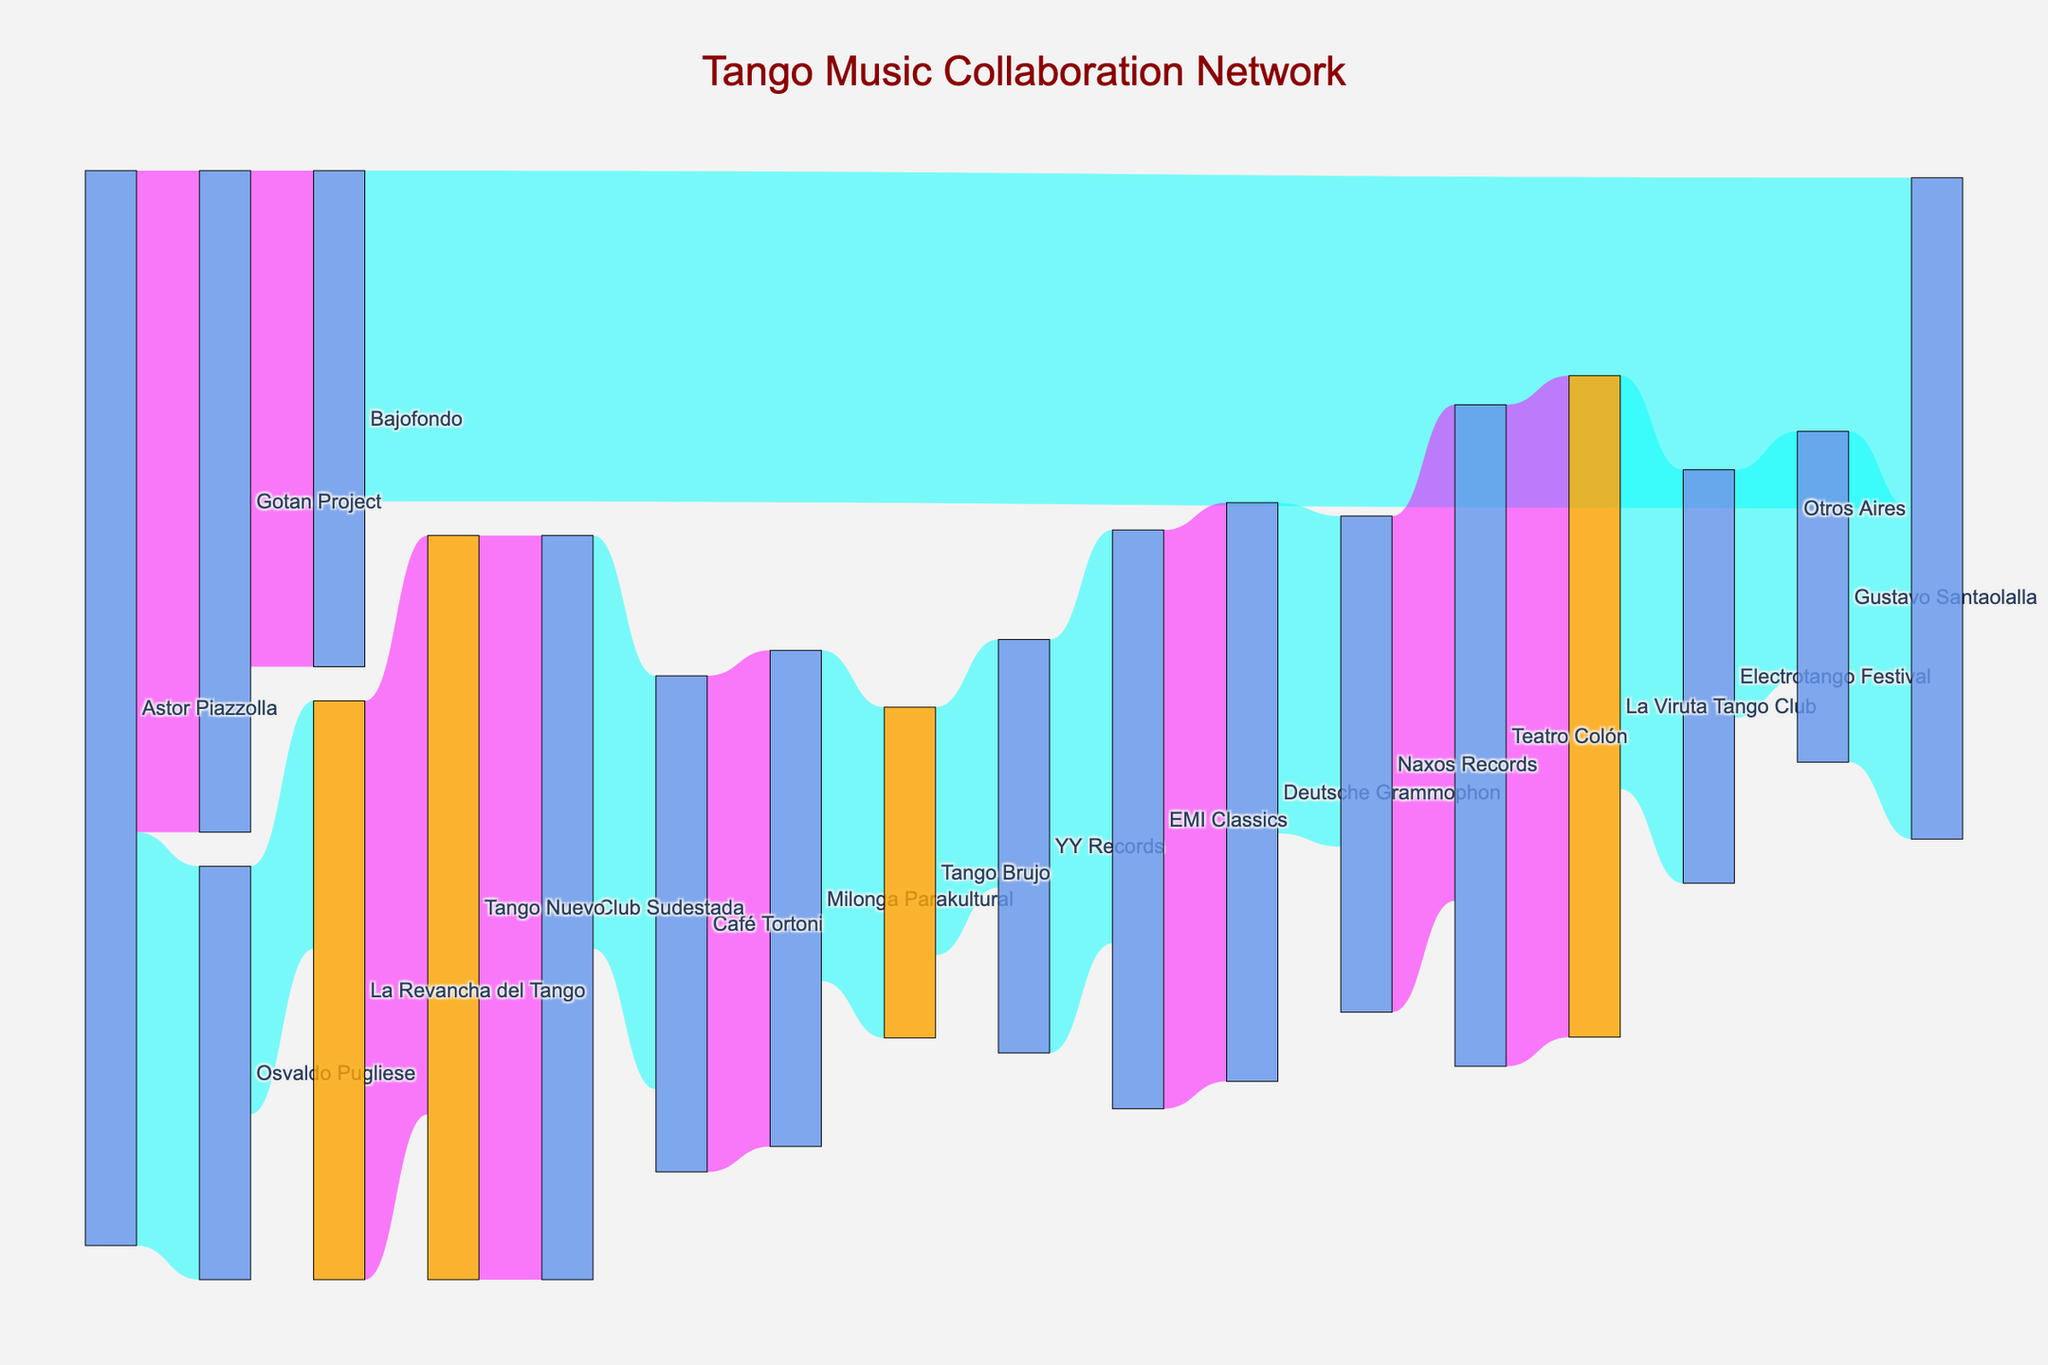how many unique nodes are present in the figure? To find the unique nodes, count all the distinct artist names, labels, and venues listed. This includes both sources and targets.
Answer: 18 what color are nodes with "Tango" in their name? Nodes with "Tango" in their name are colored with a specific hue to distinguish them. The color used is a shade of orange.
Answer: orange what is the title of the figure? The title of the figure is prominently displayed at the top. The exact text reads "Tango Music Collaboration Network".
Answer: Tango Music Collaboration Network which collaboration link has the highest value, and what is its color? To identify the highest value link, look for the link with the largest numerical value alongside it. This link is colored purple.
Answer: Tango Nuevo to Club Sudestada, purple how many collaboration links have a value greater than 5? Review the numerical values of each collaboration link and count those with values greater than 5.
Answer: 7 what is the sum of values for collaborations involving 'Astor Piazzolla'? Identify collaborations in which 'Astor Piazzolla' is involved and add the values together: 5 (with Osvaldo Pugliese) + 8 (with Gotan Project). The sum is 13.
Answer: 13 which node connects to 'Other Aires' and with what value? Identify the nodes connecting directly to 'Other Aires'. 'Other Aires' connects with 'Bajofondo' (value: 4) and 'Gustavo Santaolalla' (value: 4).
Answer: Bajofondo, 4 and Gustavo Santaolalla, 4 which node is directly connected to 'Club Sudestada' and what is the link value? Find the node that has a direct connection to 'Club Sudestada'. 'Tango Nuevo' connects to 'Club Sudestada' with a value of 9.
Answer: Tango Nuevo, 9 what is the color differentiation used for links with values greater than 5? In the diagram, links with values greater than 5 are distinguished by their color. These links are colored purple.
Answer: purple 